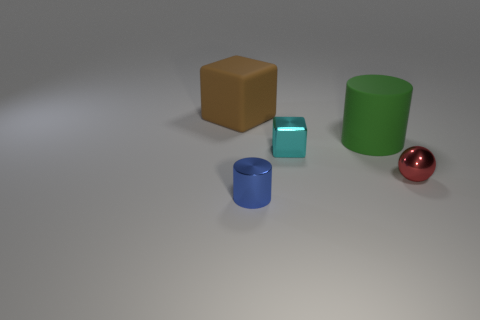Can you tell what material the objects might be made of? While it's not possible to determine the specific materials with certainty, the objects appear to have the qualities of common solids such as plastic or metal, indicated by their smooth surfaces and light-reflecting properties. 